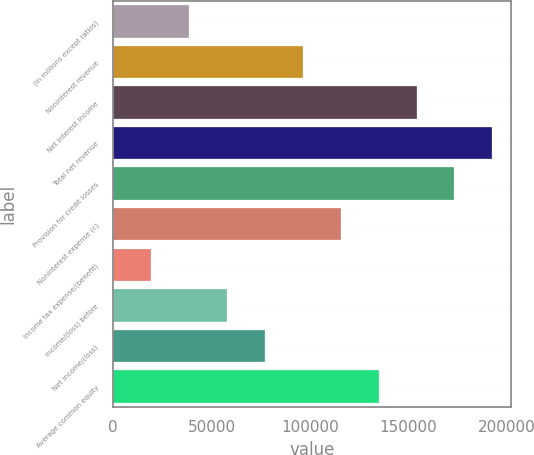Convert chart. <chart><loc_0><loc_0><loc_500><loc_500><bar_chart><fcel>(in millions except ratios)<fcel>Noninterest revenue<fcel>Net interest income<fcel>Total net revenue<fcel>Provision for credit losses<fcel>Noninterest expense (c)<fcel>Income tax expense/(benefit)<fcel>Income/(loss) before<fcel>Net income/(loss)<fcel>Average common equity<nl><fcel>38571.4<fcel>96388<fcel>154205<fcel>192749<fcel>173477<fcel>115660<fcel>19299.2<fcel>57843.6<fcel>77115.8<fcel>134932<nl></chart> 